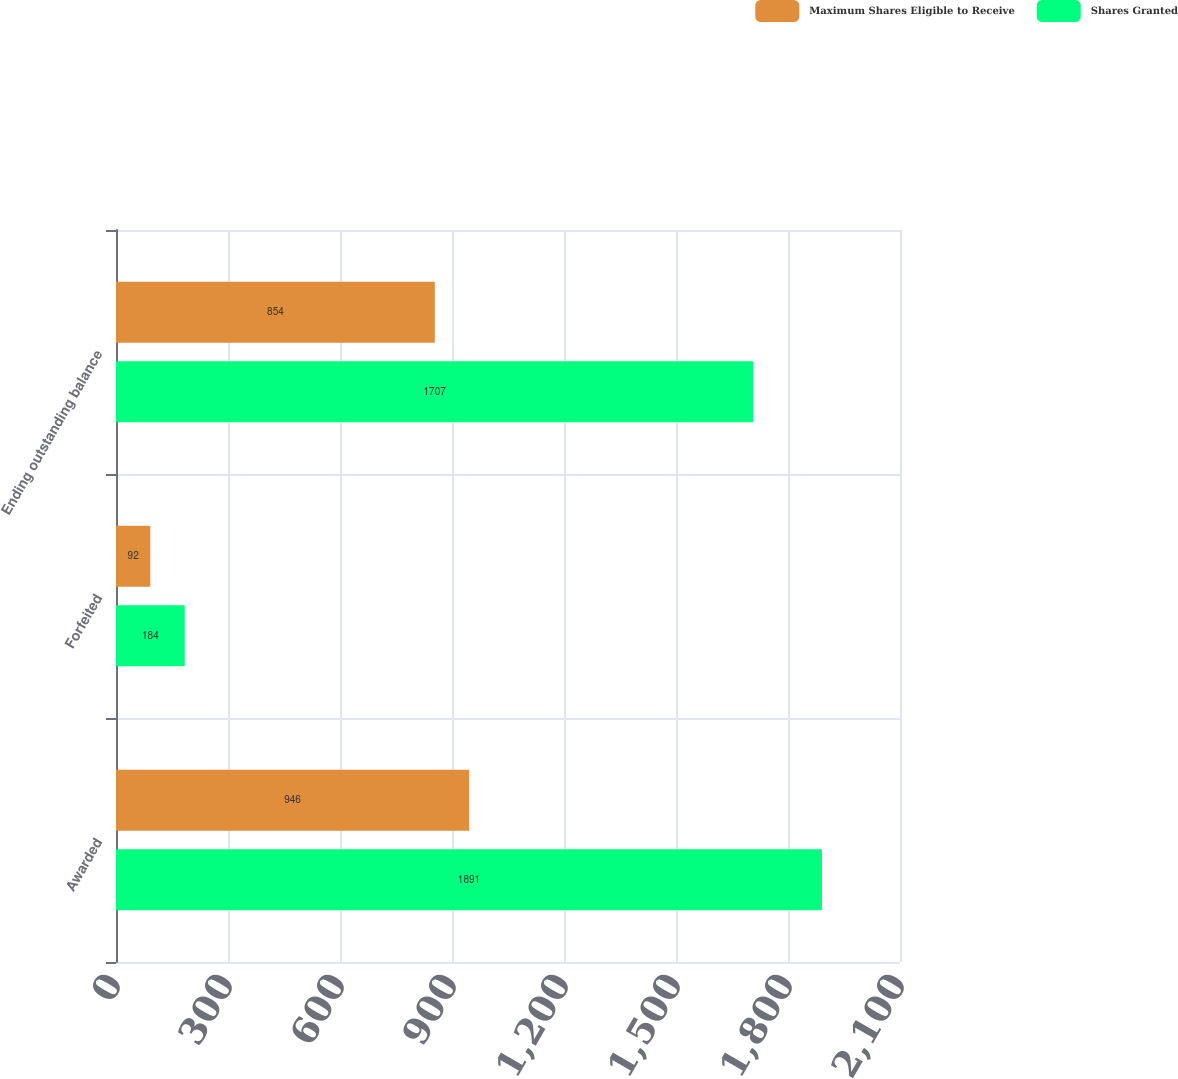Convert chart. <chart><loc_0><loc_0><loc_500><loc_500><stacked_bar_chart><ecel><fcel>Awarded<fcel>Forfeited<fcel>Ending outstanding balance<nl><fcel>Maximum Shares Eligible to Receive<fcel>946<fcel>92<fcel>854<nl><fcel>Shares Granted<fcel>1891<fcel>184<fcel>1707<nl></chart> 